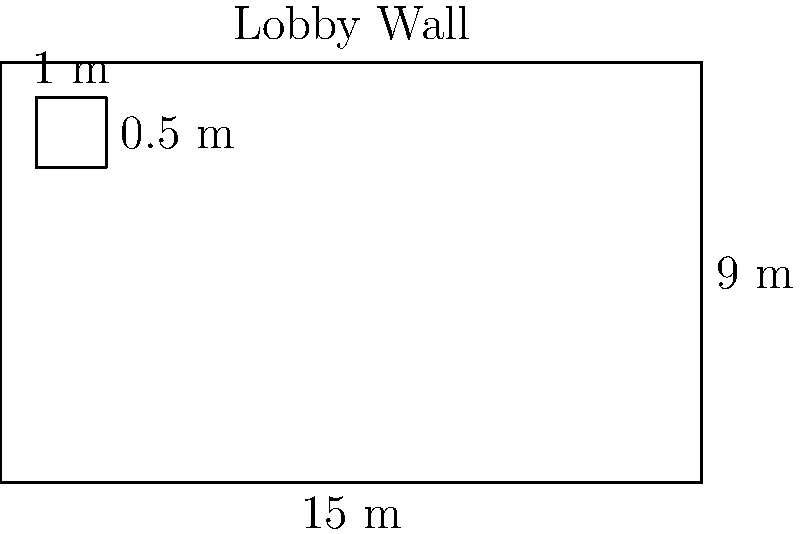You're planning to cover a lobby wall with custom wooden panels. The wall measures 15 meters wide and 9 meters high, as shown in the diagram. Each wooden panel is 1 meter wide and 0.5 meters high. How many wooden panels will you need to cover the entire wall? To determine the number of wooden panels needed, we'll follow these steps:

1. Calculate the total area of the wall:
   Area of wall = Width × Height
   $$ A_{wall} = 15 \text{ m} \times 9 \text{ m} = 135 \text{ m}^2 $$

2. Calculate the area of one wooden panel:
   Area of panel = Width × Height
   $$ A_{panel} = 1 \text{ m} \times 0.5 \text{ m} = 0.5 \text{ m}^2 $$

3. Calculate the number of panels needed:
   Number of panels = Area of wall ÷ Area of panel
   $$ N_{panels} = \frac{A_{wall}}{A_{panel}} = \frac{135 \text{ m}^2}{0.5 \text{ m}^2} = 270 $$

Therefore, you will need 270 wooden panels to cover the entire lobby wall.
Answer: 270 panels 